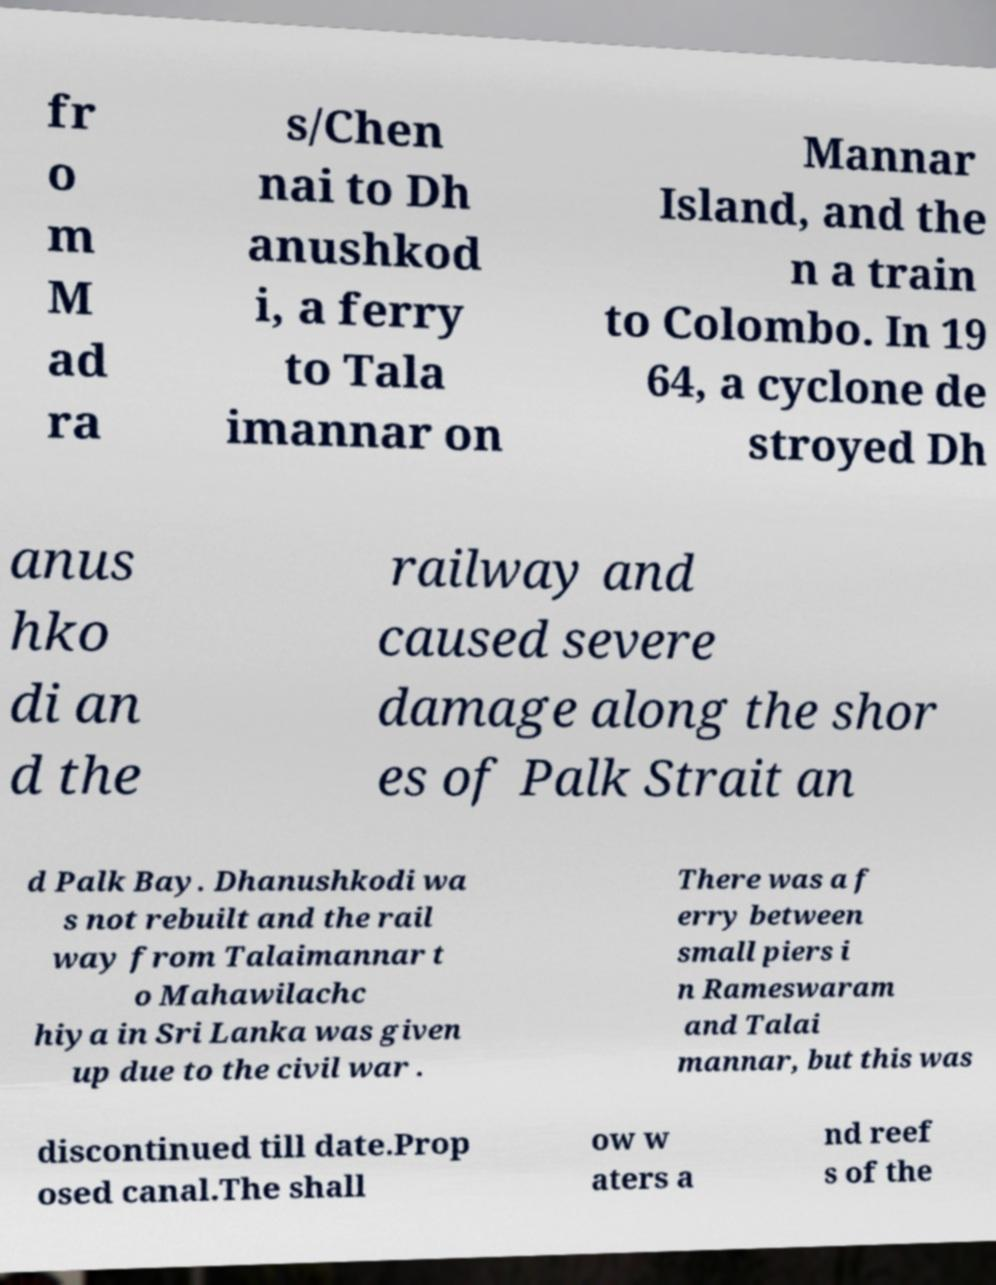Could you assist in decoding the text presented in this image and type it out clearly? fr o m M ad ra s/Chen nai to Dh anushkod i, a ferry to Tala imannar on Mannar Island, and the n a train to Colombo. In 19 64, a cyclone de stroyed Dh anus hko di an d the railway and caused severe damage along the shor es of Palk Strait an d Palk Bay. Dhanushkodi wa s not rebuilt and the rail way from Talaimannar t o Mahawilachc hiya in Sri Lanka was given up due to the civil war . There was a f erry between small piers i n Rameswaram and Talai mannar, but this was discontinued till date.Prop osed canal.The shall ow w aters a nd reef s of the 